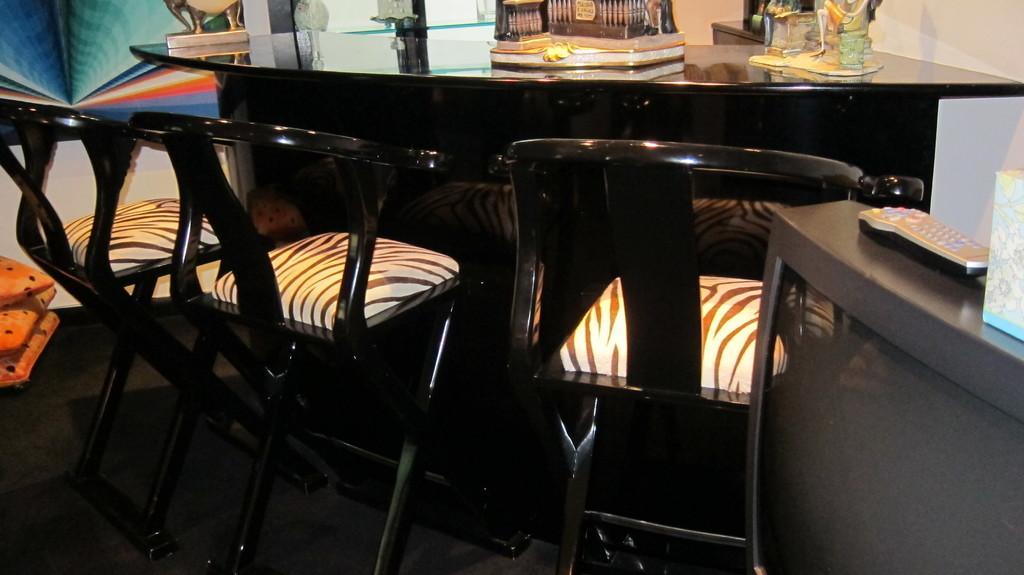Could you give a brief overview of what you see in this image? In the image I can see there is a table with some objects on it, beside the table there are some chairs. 